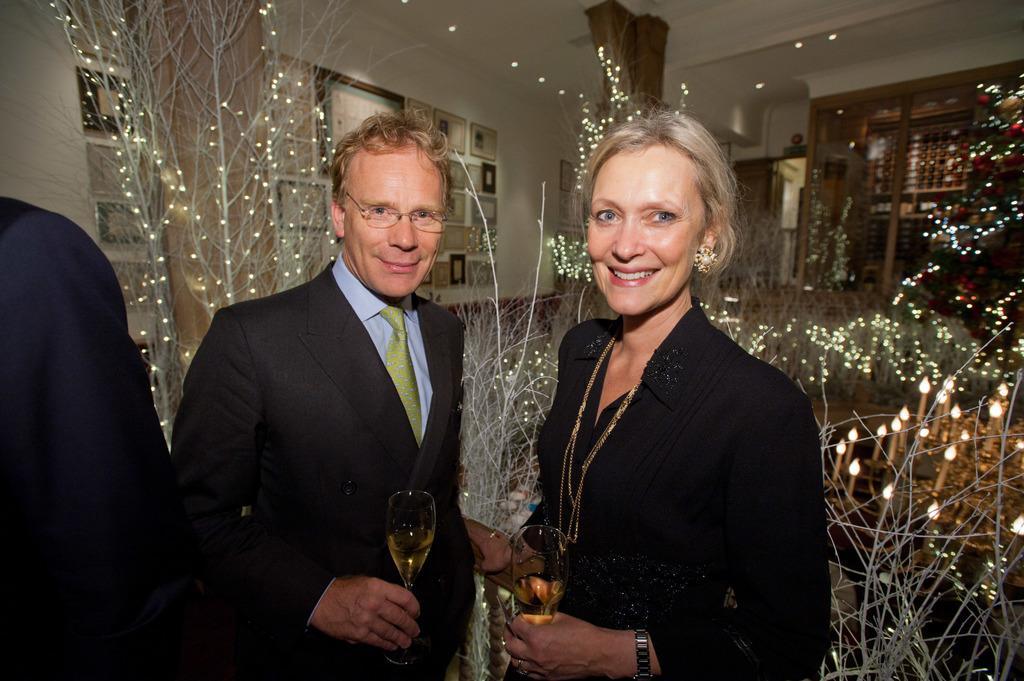Describe this image in one or two sentences. In this picture we can see three people where a man and a woman holding glasses with their hands and smiling and in the background we can see lights, frames on the wall. 